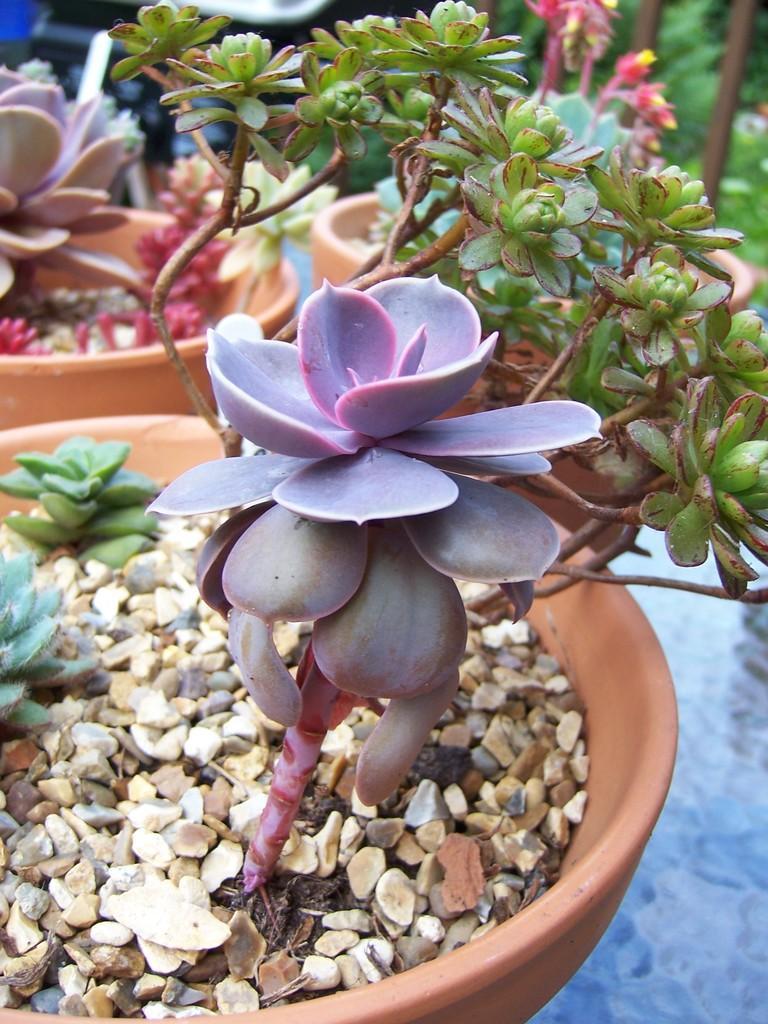Could you give a brief overview of what you see in this image? In this picture, i can see few plants in the pots and few small stones. 